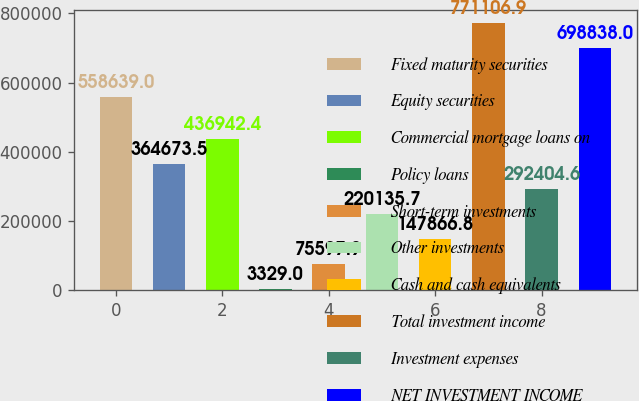<chart> <loc_0><loc_0><loc_500><loc_500><bar_chart><fcel>Fixed maturity securities<fcel>Equity securities<fcel>Commercial mortgage loans on<fcel>Policy loans<fcel>Short-term investments<fcel>Other investments<fcel>Cash and cash equivalents<fcel>Total investment income<fcel>Investment expenses<fcel>NET INVESTMENT INCOME<nl><fcel>558639<fcel>364674<fcel>436942<fcel>3329<fcel>75597.9<fcel>220136<fcel>147867<fcel>771107<fcel>292405<fcel>698838<nl></chart> 